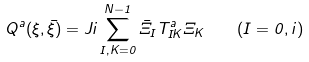<formula> <loc_0><loc_0><loc_500><loc_500>Q ^ { a } ( \xi , \bar { \xi } ) = J i \sum _ { I , K = 0 } ^ { N - 1 } { \bar { \Xi } } _ { I } T ^ { a } _ { I K } \Xi _ { K } \quad ( I = 0 , i )</formula> 